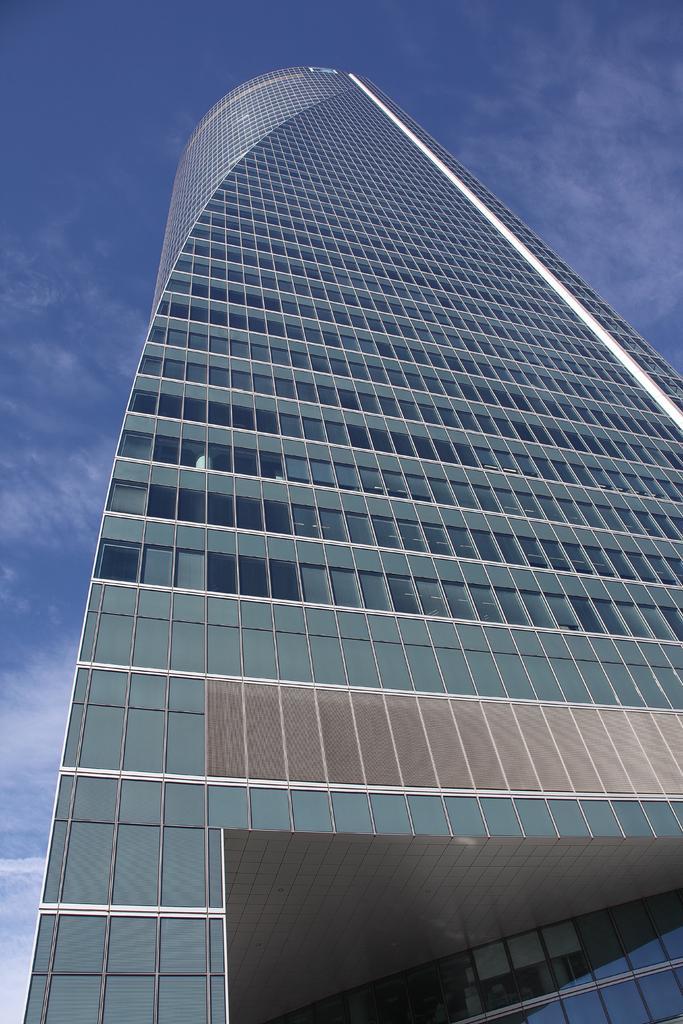Describe this image in one or two sentences. Here in this picture we can see a building present over there and we can see clouds in the sky over there. 